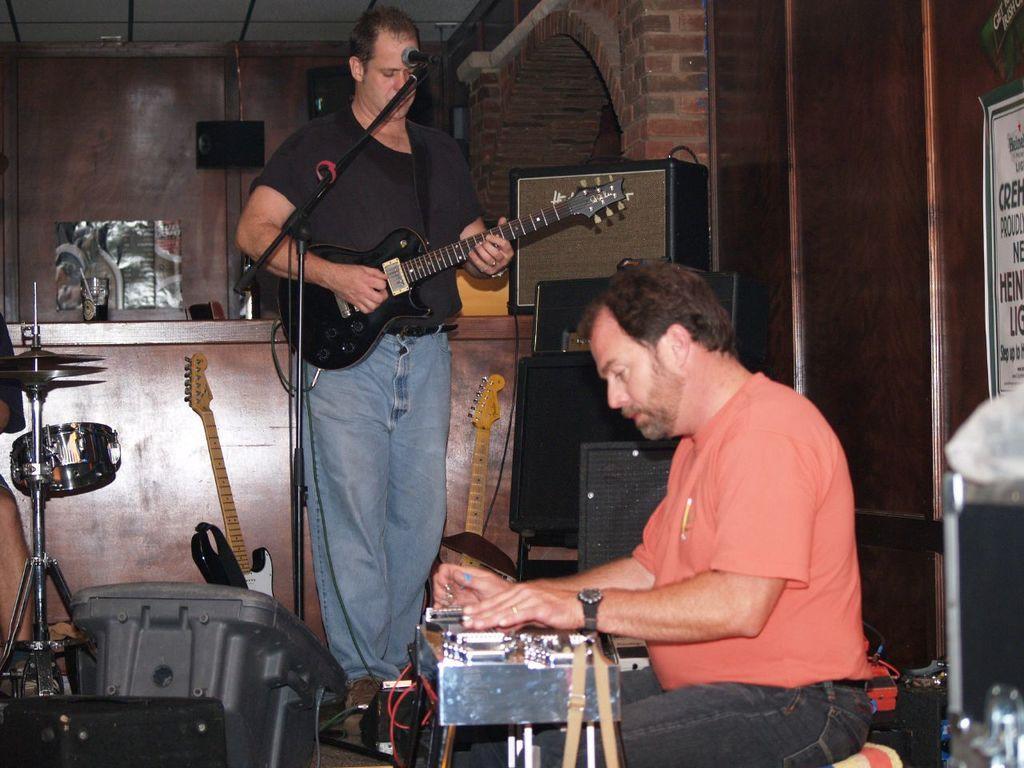Describe this image in one or two sentences. The image consists of two men in which one of them is playing the guitar while the other is sitting. To the left side there are drums and musical plates. At the background there is a wall,poster,jar which is kept on table and the speaker. There is a mic in front of the man who is standing. 